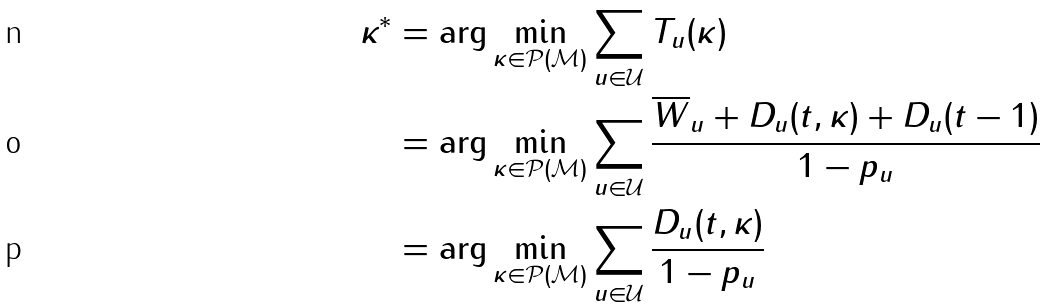Convert formula to latex. <formula><loc_0><loc_0><loc_500><loc_500>\kappa ^ { * } & = \arg \min _ { \kappa \in \mathcal { P } ( \mathcal { M } ) } \sum _ { u \in \mathcal { U } } T _ { u } ( \kappa ) \\ & = \arg \min _ { \kappa \in \mathcal { P } ( \mathcal { M } ) } \sum _ { u \in \mathcal { U } } \cfrac { \overline { W } _ { u } + D _ { u } ( t , \kappa ) + D _ { u } ( t - 1 ) } { 1 - p _ { u } } \\ & = \arg \min _ { \kappa \in \mathcal { P } ( \mathcal { M } ) } \sum _ { u \in \mathcal { U } } \cfrac { D _ { u } ( t , \kappa ) } { 1 - p _ { u } }</formula> 